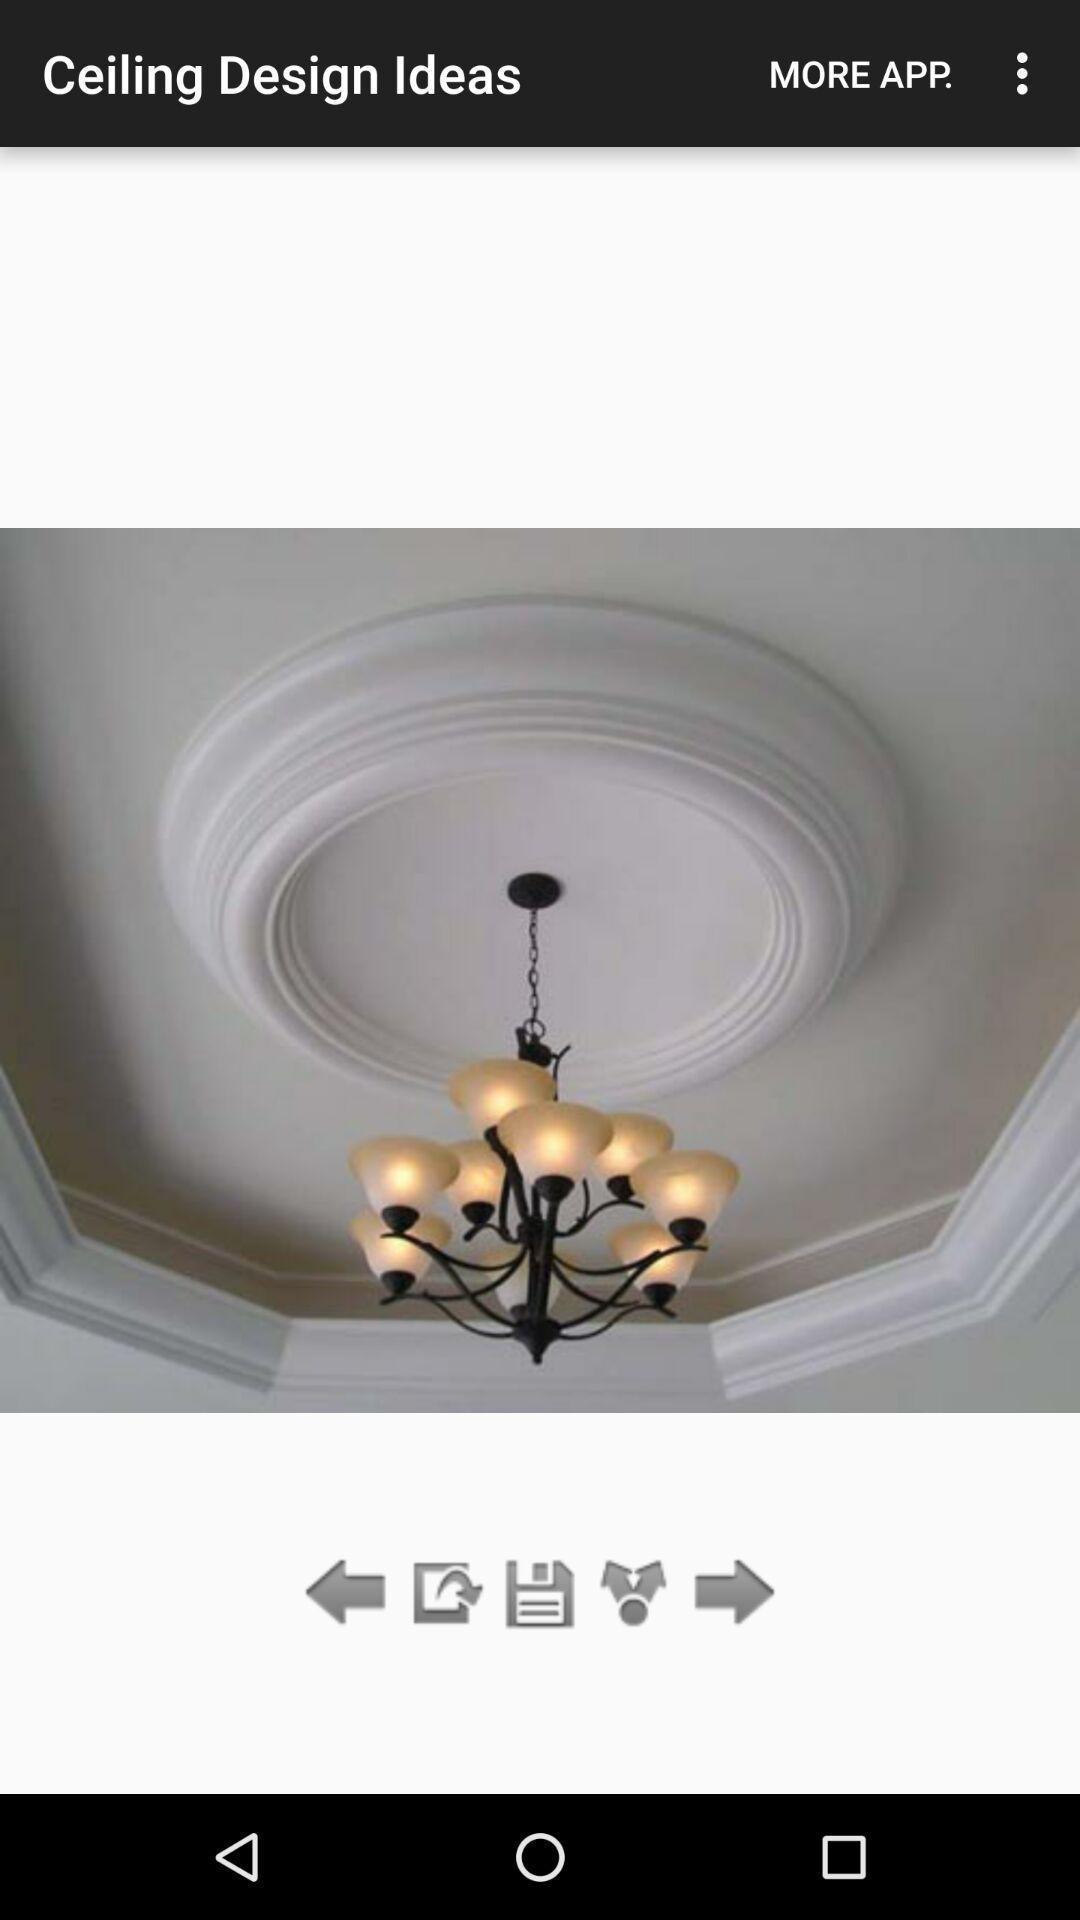What can you discern from this picture? Page showing an image for interior designs. 